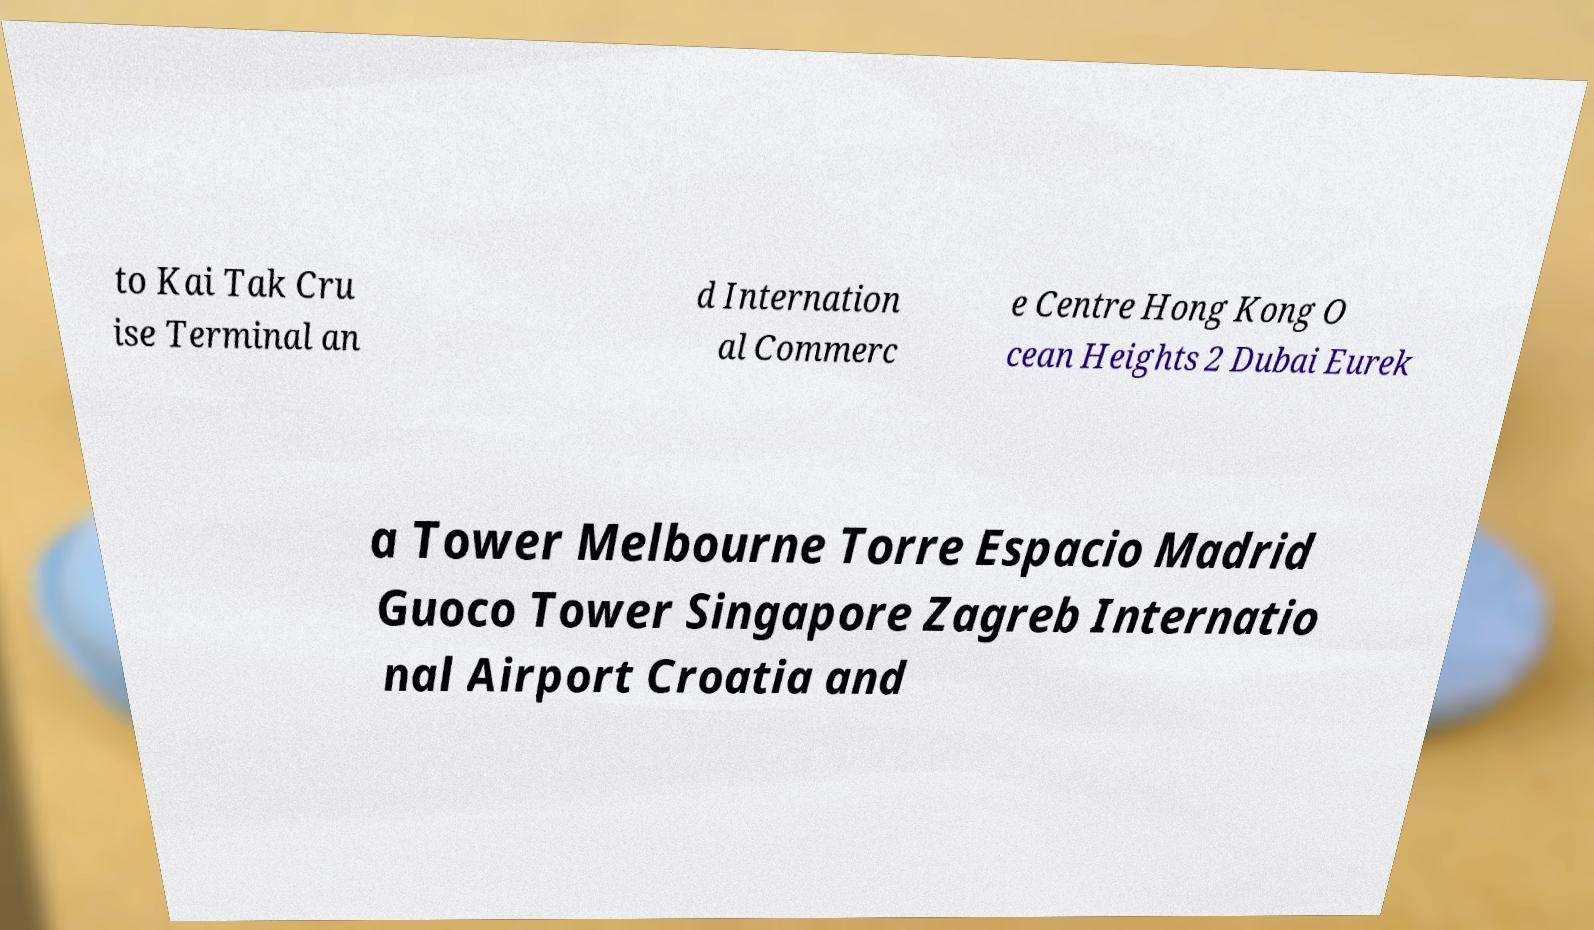Can you accurately transcribe the text from the provided image for me? to Kai Tak Cru ise Terminal an d Internation al Commerc e Centre Hong Kong O cean Heights 2 Dubai Eurek a Tower Melbourne Torre Espacio Madrid Guoco Tower Singapore Zagreb Internatio nal Airport Croatia and 